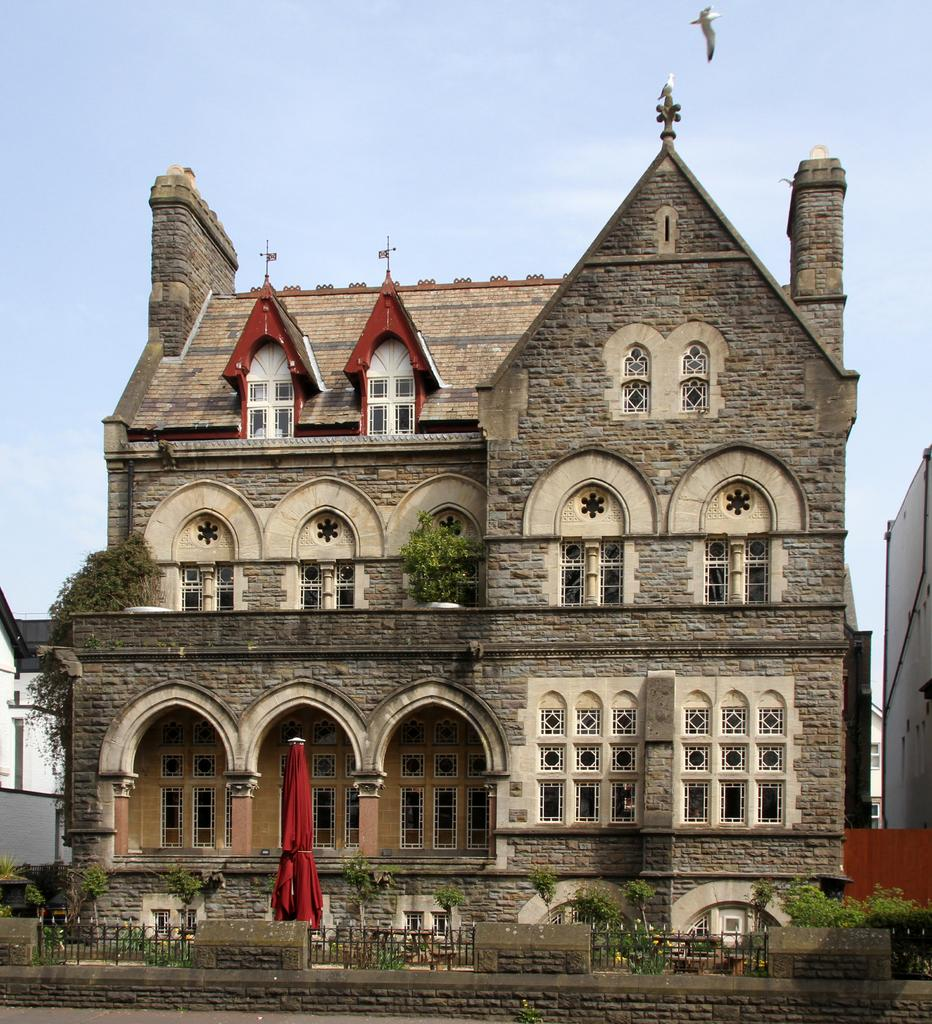What is the main structure in the middle of the image? There is a building in the middle of the image. What type of vegetation is present at the bottom of the image? There are bushes at the bottom of the image. What can be seen in the sky in the image? The sky is visible at the top of the image, and a bird is flying in it. Where is the girl playing with the apparatus in the image? There is no girl or apparatus present in the image. What type of garden is visible in the image? There is no garden present in the image. 